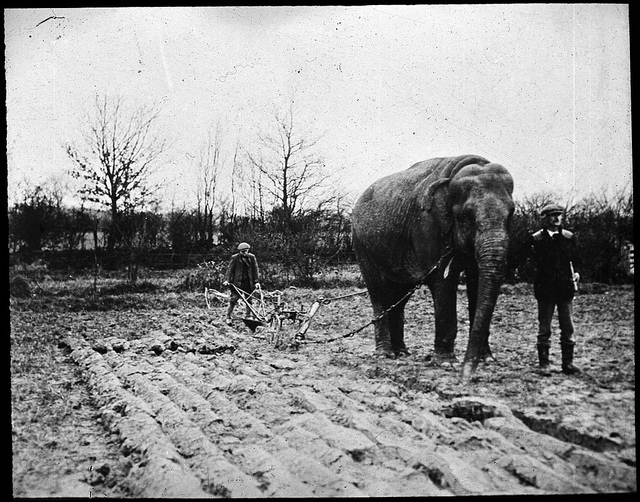<image>In what year was this picture taken? I don't know in what year this picture was taken. It's impossible to tell. In what year was this picture taken? I don't know in what year this picture was taken. It can be any year between 1860 and 1958. 